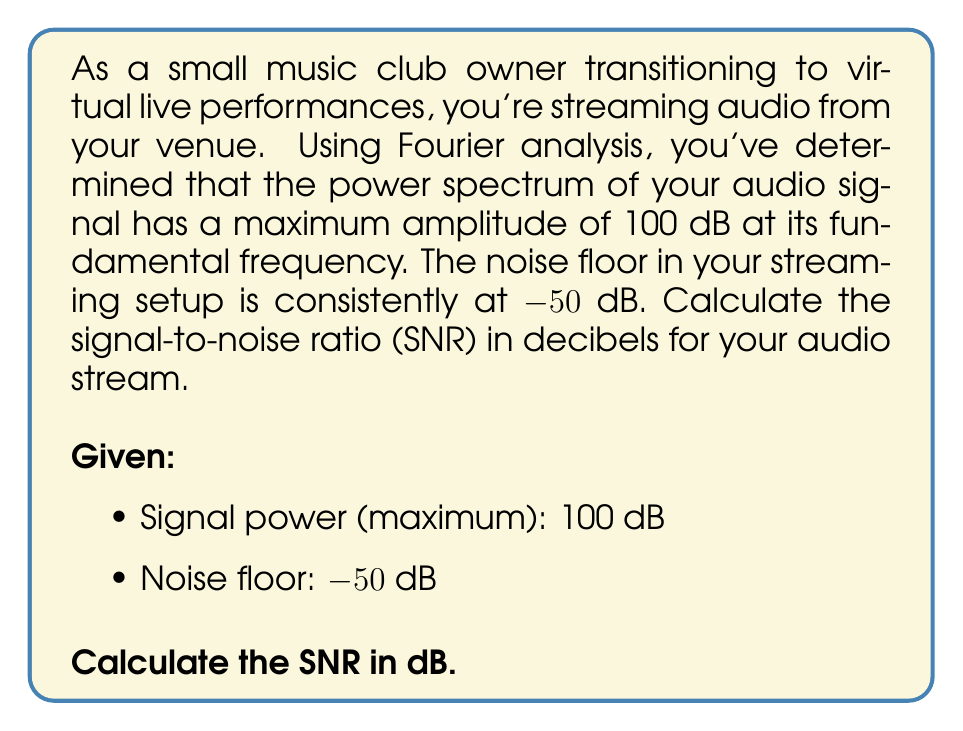What is the answer to this math problem? To solve this problem, we'll follow these steps:

1) Recall the formula for Signal-to-Noise Ratio (SNR) in decibels:

   $$ SNR_{dB} = 10 \log_{10}\left(\frac{P_{signal}}{P_{noise}}\right) $$

   Where $P_{signal}$ is the power of the signal and $P_{noise}$ is the power of the noise.

2) In our case, we're given the signal and noise levels in decibels. We need to convert these back to linear power ratios. The formula to convert from dB to power ratio is:

   $$ P = 10^{\frac{dB}{10}} $$

3) For the signal:
   $$ P_{signal} = 10^{\frac{100}{10}} = 10^{10} $$

4) For the noise:
   $$ P_{noise} = 10^{\frac{-50}{10}} = 10^{-5} $$

5) Now we can plug these values into our SNR formula:

   $$ SNR_{dB} = 10 \log_{10}\left(\frac{10^{10}}{10^{-5}}\right) $$

6) Simplify inside the parentheses:
   $$ SNR_{dB} = 10 \log_{10}(10^{15}) $$

7) Apply the logarithm property $\log_a(x^n) = n\log_a(x)$:
   $$ SNR_{dB} = 10 (15 \log_{10}(10)) $$

8) $\log_{10}(10) = 1$, so:
   $$ SNR_{dB} = 10 (15) = 150 $$

Therefore, the Signal-to-Noise Ratio is 150 dB.
Answer: 150 dB 